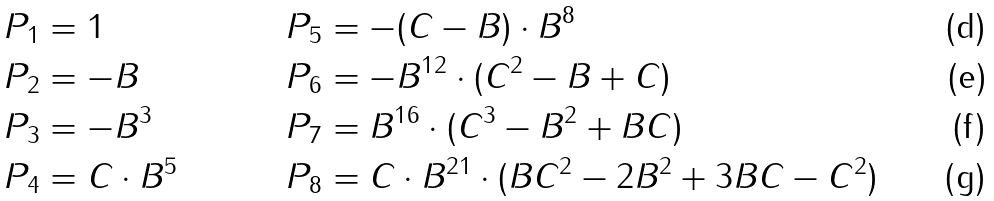Convert formula to latex. <formula><loc_0><loc_0><loc_500><loc_500>P _ { 1 } & = 1 & P _ { 5 } & = - ( C - B ) \cdot B ^ { 8 } \\ P _ { 2 } & = - B & P _ { 6 } & = - B ^ { 1 2 } \cdot ( C ^ { 2 } - B + C ) \\ P _ { 3 } & = - B ^ { 3 } & P _ { 7 } & = B ^ { 1 6 } \cdot ( C ^ { 3 } - B ^ { 2 } + B C ) \\ P _ { 4 } & = C \cdot B ^ { 5 } & P _ { 8 } & = C \cdot B ^ { 2 1 } \cdot ( B C ^ { 2 } - 2 B ^ { 2 } + 3 B C - C ^ { 2 } )</formula> 